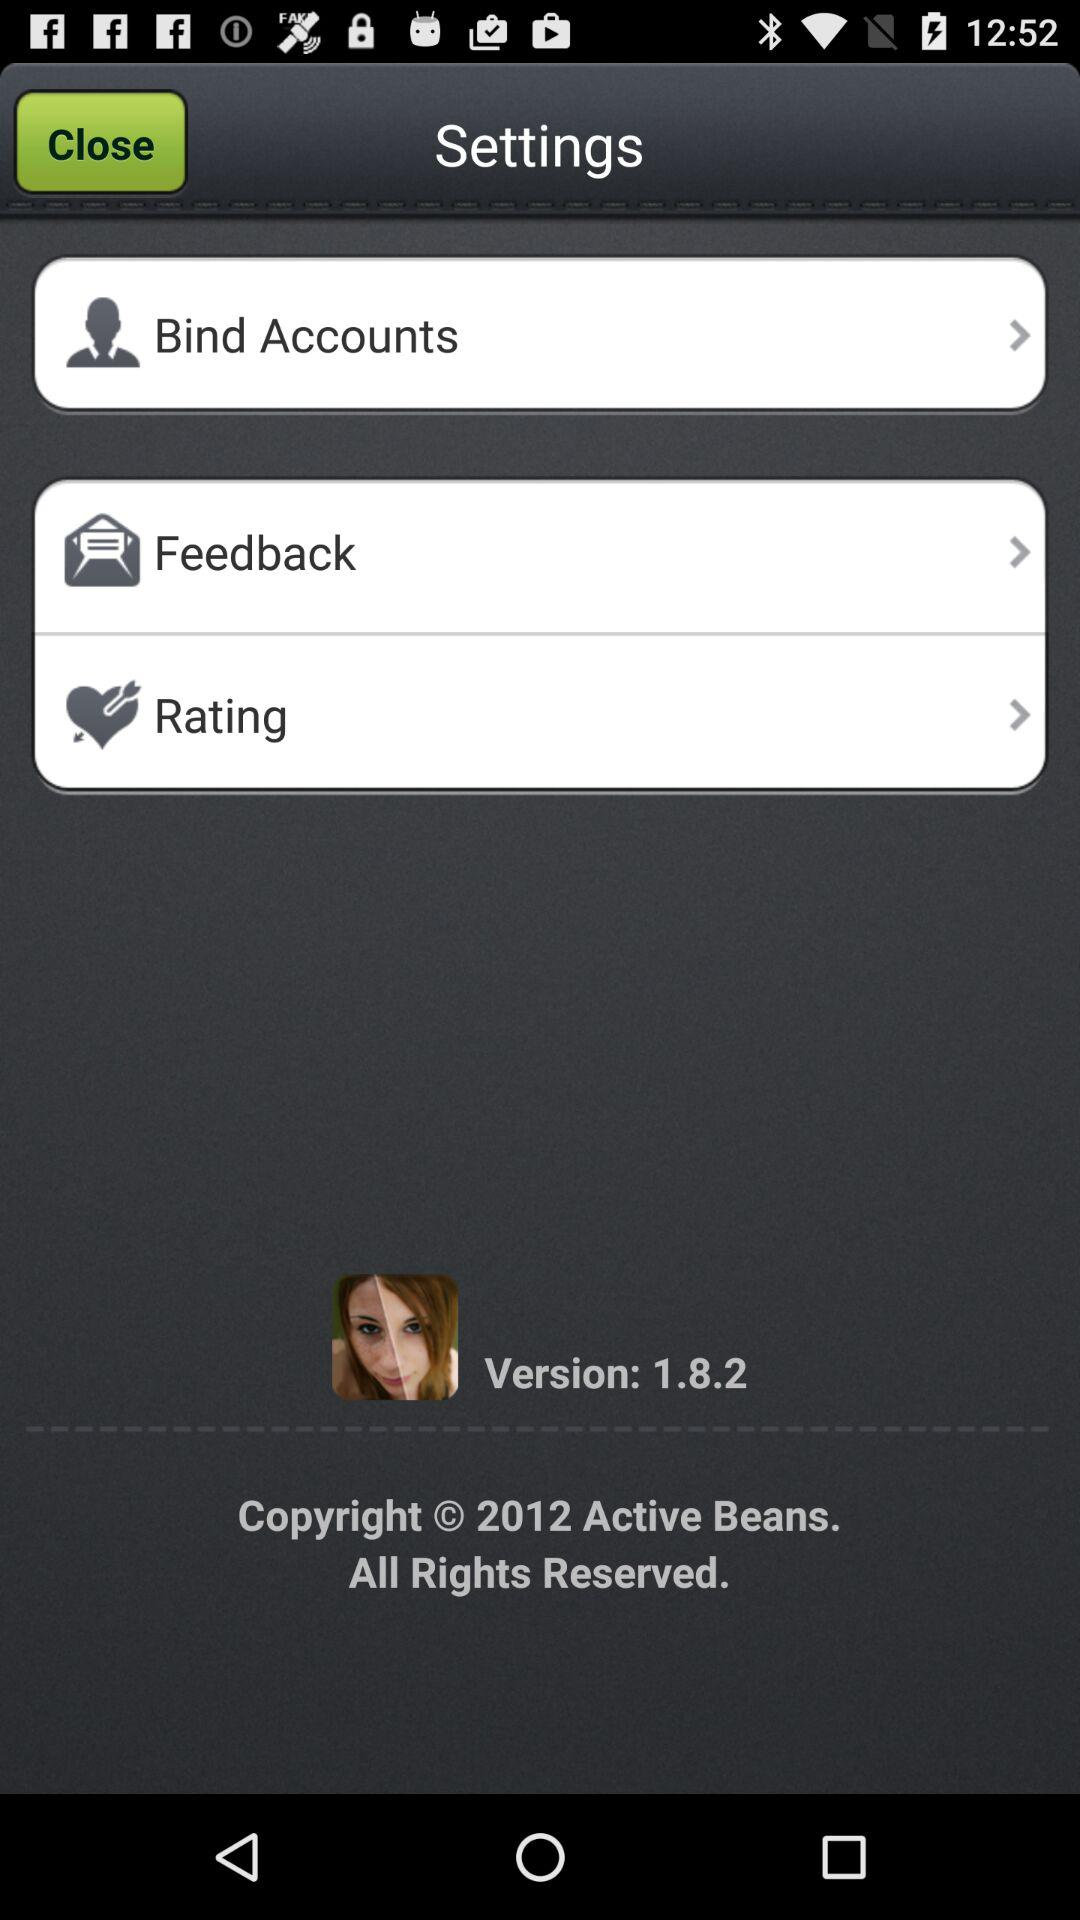What is the version number? The version number is 1.8.2. 